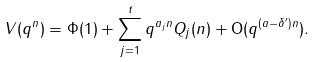<formula> <loc_0><loc_0><loc_500><loc_500>V ( q ^ { n } ) = \Phi ( 1 ) + \sum _ { j = 1 } ^ { t } q ^ { a _ { j } n } Q _ { j } ( n ) + \mathrm O ( q ^ { ( a - \delta ^ { \prime } ) n } ) .</formula> 